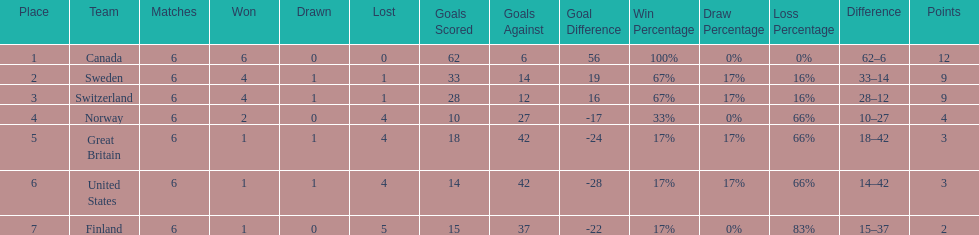How many teams won at least 2 games throughout the 1951 world ice hockey championships? 4. 